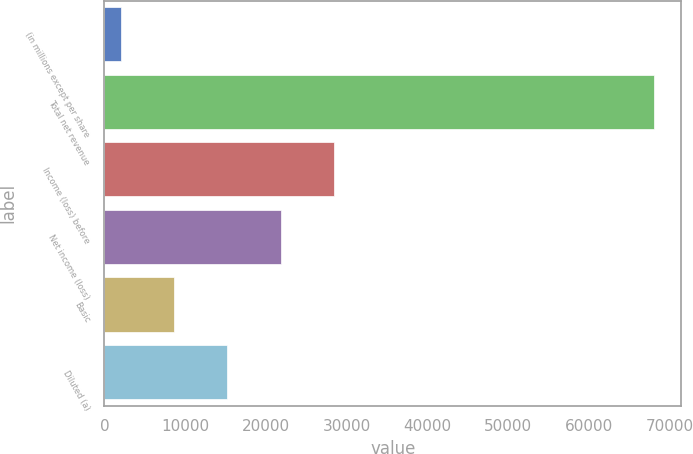Convert chart to OTSL. <chart><loc_0><loc_0><loc_500><loc_500><bar_chart><fcel>(in millions except per share<fcel>Total net revenue<fcel>Income (loss) before<fcel>Net income (loss)<fcel>Basic<fcel>Diluted (a)<nl><fcel>2008<fcel>68071<fcel>28433.2<fcel>21826.9<fcel>8614.3<fcel>15220.6<nl></chart> 